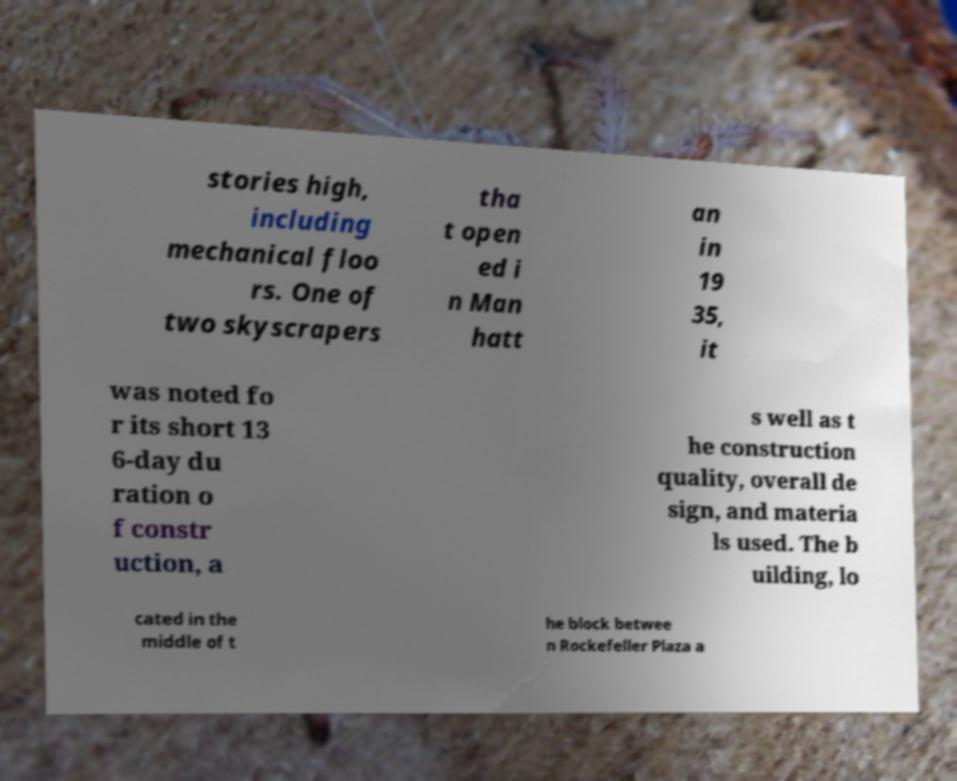Please read and relay the text visible in this image. What does it say? stories high, including mechanical floo rs. One of two skyscrapers tha t open ed i n Man hatt an in 19 35, it was noted fo r its short 13 6-day du ration o f constr uction, a s well as t he construction quality, overall de sign, and materia ls used. The b uilding, lo cated in the middle of t he block betwee n Rockefeller Plaza a 